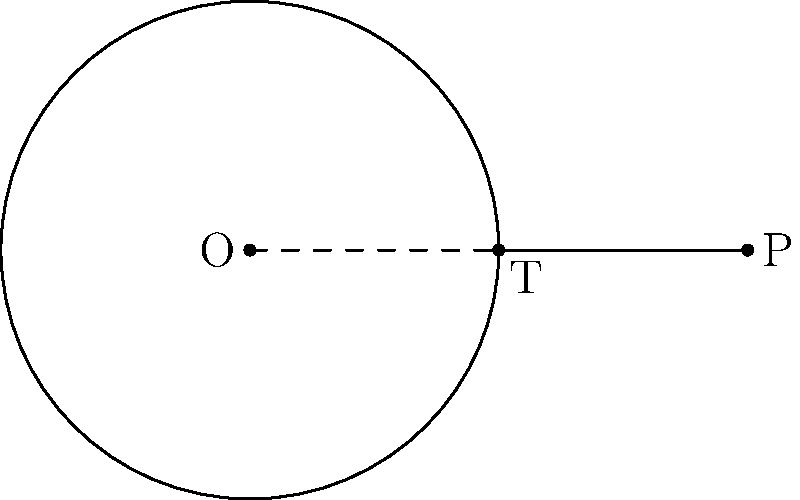In the context of PromiseKit, imagine you're working on a feature that requires calculating distances. You encounter a problem where you need to determine the length of a tangent line from an external point to a circle. Given a circle with center O and radius $r = 3$ units, and an external point P at a distance of 6 units from O, what is the length of the tangent line PT? Let's approach this step-by-step, similar to how we might break down a complex asynchronous operation in PromiseKit:

1) First, we can identify that triangle OPT is a right-angled triangle, with the right angle at T (as the tangent line is perpendicular to the radius at the point of tangency).

2) We know:
   - OT is a radius, so OT = $r = 3$
   - OP = 6 (given in the question)
   - Let PT = $x$ (this is what we're trying to find)

3) We can apply the Pythagorean theorem to triangle OPT:
   $$OP^2 = OT^2 + PT^2$$

4) Substituting the known values:
   $$6^2 = 3^2 + x^2$$

5) Simplify:
   $$36 = 9 + x^2$$

6) Subtract 9 from both sides:
   $$27 = x^2$$

7) Take the square root of both sides:
   $$x = \sqrt{27} = 3\sqrt{3}$$

Therefore, the length of the tangent line PT is $3\sqrt{3}$ units.
Answer: $3\sqrt{3}$ units 